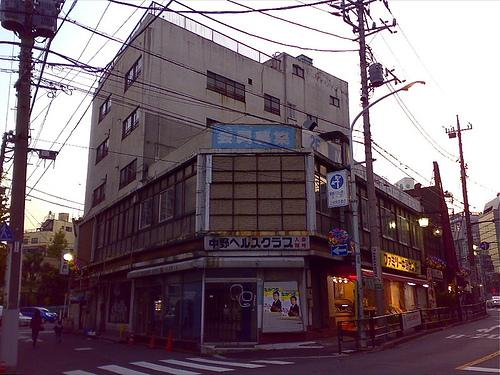Question: what color is the sky?
Choices:
A. Black.
B. Red.
C. Gray.
D. Blue.
Answer with the letter. Answer: C Question: how many telephone poles are there?
Choices:
A. Three.
B. One.
C. Two.
D. Four.
Answer with the letter. Answer: A Question: where was the picture taken?
Choices:
A. At a park.
B. In a house.
C. On the street corner.
D. At a pool.
Answer with the letter. Answer: C 